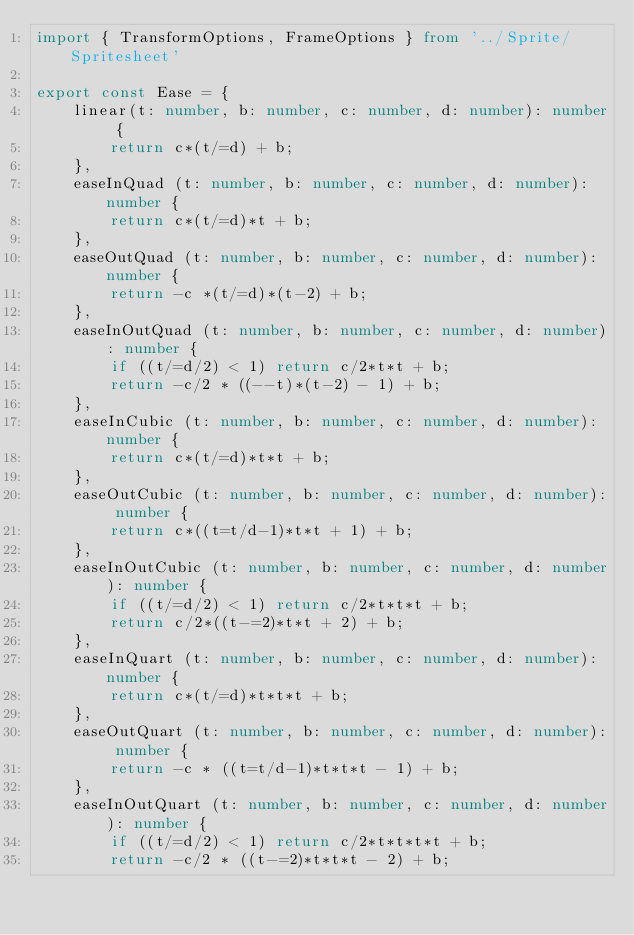<code> <loc_0><loc_0><loc_500><loc_500><_TypeScript_>import { TransformOptions, FrameOptions } from '../Sprite/Spritesheet'

export const Ease = {
	linear(t: number, b: number, c: number, d: number): number {
		return c*(t/=d) + b;
	},
	easeInQuad (t: number, b: number, c: number, d: number): number {
		return c*(t/=d)*t + b;
	},
	easeOutQuad (t: number, b: number, c: number, d: number): number {
		return -c *(t/=d)*(t-2) + b;
	},
	easeInOutQuad (t: number, b: number, c: number, d: number): number {
		if ((t/=d/2) < 1) return c/2*t*t + b;
		return -c/2 * ((--t)*(t-2) - 1) + b;
	},
	easeInCubic (t: number, b: number, c: number, d: number): number {
		return c*(t/=d)*t*t + b;
	},
	easeOutCubic (t: number, b: number, c: number, d: number): number {
		return c*((t=t/d-1)*t*t + 1) + b;
	},
	easeInOutCubic (t: number, b: number, c: number, d: number): number {
		if ((t/=d/2) < 1) return c/2*t*t*t + b;
		return c/2*((t-=2)*t*t + 2) + b;
	},
	easeInQuart (t: number, b: number, c: number, d: number): number {
		return c*(t/=d)*t*t*t + b;
	},
	easeOutQuart (t: number, b: number, c: number, d: number): number {
		return -c * ((t=t/d-1)*t*t*t - 1) + b;
	},
	easeInOutQuart (t: number, b: number, c: number, d: number): number {
		if ((t/=d/2) < 1) return c/2*t*t*t*t + b;
		return -c/2 * ((t-=2)*t*t*t - 2) + b;</code> 